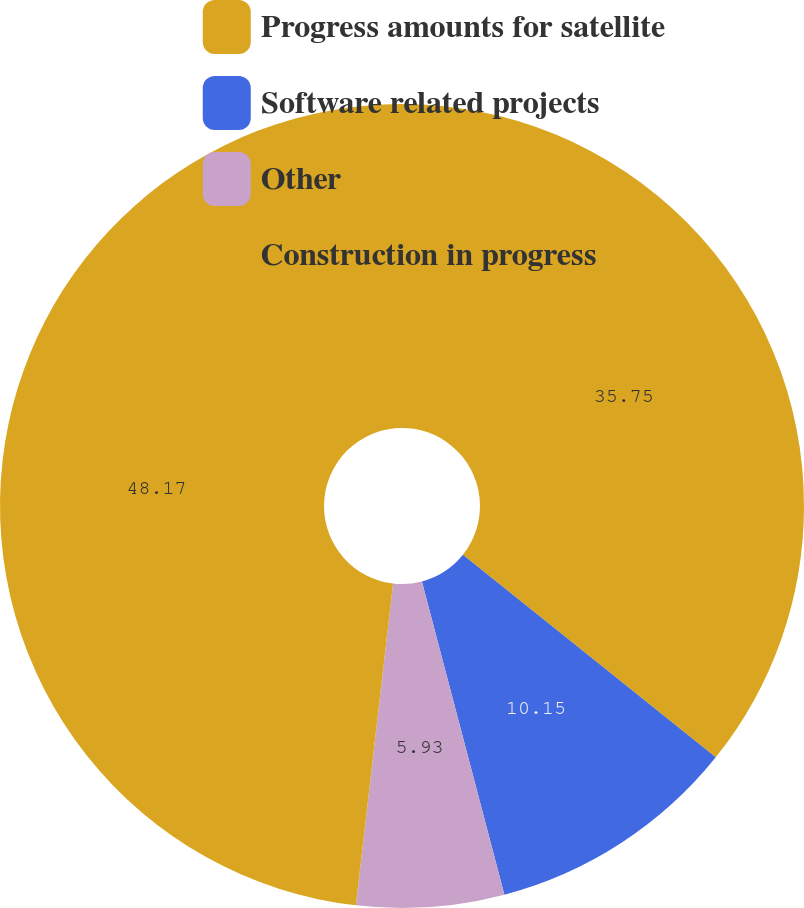Convert chart. <chart><loc_0><loc_0><loc_500><loc_500><pie_chart><fcel>Progress amounts for satellite<fcel>Software related projects<fcel>Other<fcel>Construction in progress<nl><fcel>35.75%<fcel>10.15%<fcel>5.93%<fcel>48.17%<nl></chart> 